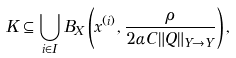Convert formula to latex. <formula><loc_0><loc_0><loc_500><loc_500>K \subseteq \bigcup _ { i \in I } B _ { X } \left ( x ^ { ( i ) } , \frac { \rho } { 2 \alpha C \| Q \| _ { Y \to Y } } \right ) ,</formula> 